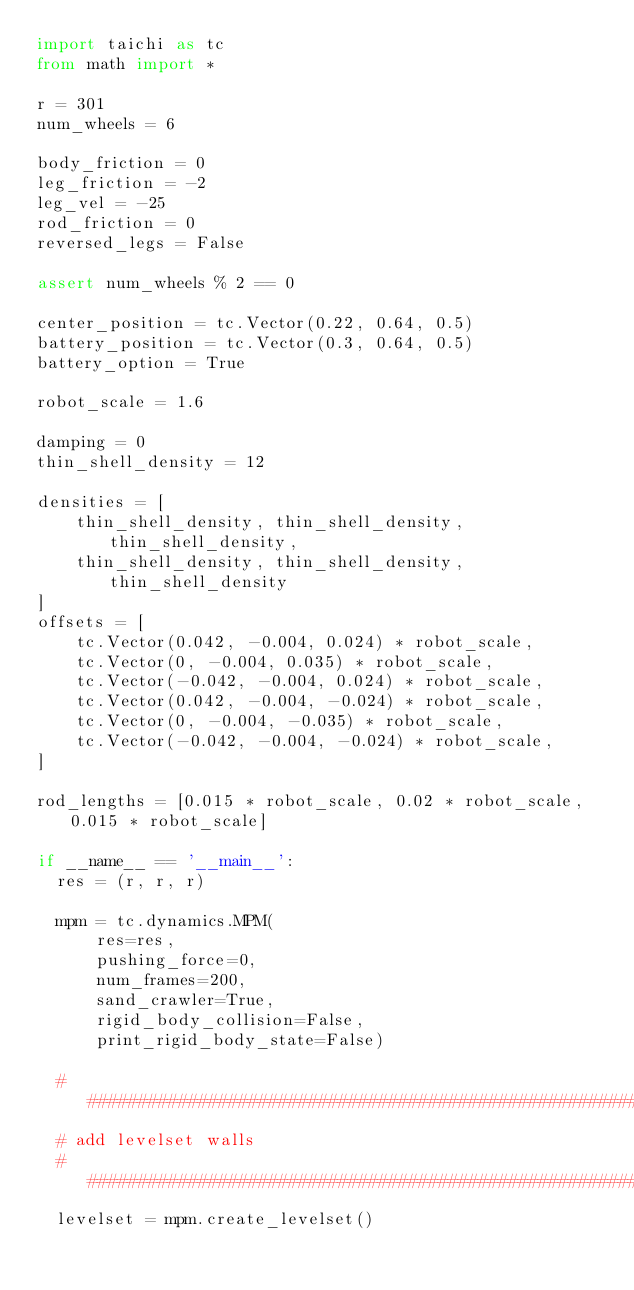<code> <loc_0><loc_0><loc_500><loc_500><_Python_>import taichi as tc
from math import *

r = 301
num_wheels = 6

body_friction = 0
leg_friction = -2
leg_vel = -25
rod_friction = 0
reversed_legs = False

assert num_wheels % 2 == 0

center_position = tc.Vector(0.22, 0.64, 0.5)
battery_position = tc.Vector(0.3, 0.64, 0.5)
battery_option = True

robot_scale = 1.6

damping = 0
thin_shell_density = 12

densities = [
    thin_shell_density, thin_shell_density, thin_shell_density,
    thin_shell_density, thin_shell_density, thin_shell_density
]
offsets = [
    tc.Vector(0.042, -0.004, 0.024) * robot_scale,
    tc.Vector(0, -0.004, 0.035) * robot_scale,
    tc.Vector(-0.042, -0.004, 0.024) * robot_scale,
    tc.Vector(0.042, -0.004, -0.024) * robot_scale,
    tc.Vector(0, -0.004, -0.035) * robot_scale,
    tc.Vector(-0.042, -0.004, -0.024) * robot_scale,
]

rod_lengths = [0.015 * robot_scale, 0.02 * robot_scale, 0.015 * robot_scale]

if __name__ == '__main__':
  res = (r, r, r)

  mpm = tc.dynamics.MPM(
      res=res,
      pushing_force=0,
      num_frames=200,
      sand_crawler=True,
      rigid_body_collision=False,
      print_rigid_body_state=False)

  ###########################################################################
  # add levelset walls
  ###########################################################################
  levelset = mpm.create_levelset()</code> 